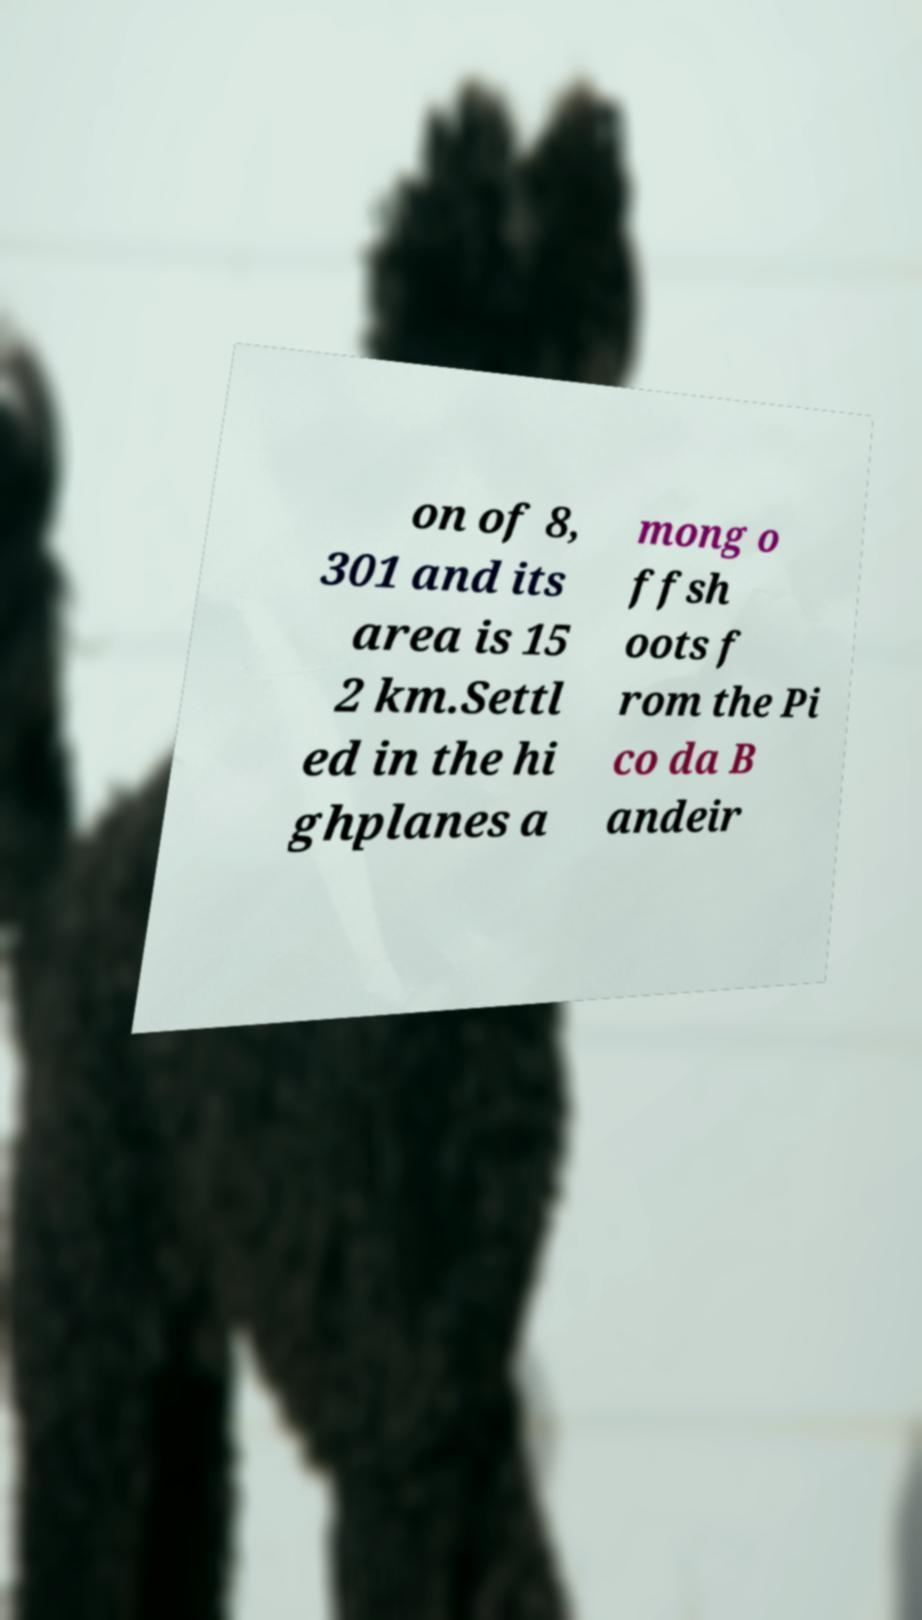Can you read and provide the text displayed in the image?This photo seems to have some interesting text. Can you extract and type it out for me? on of 8, 301 and its area is 15 2 km.Settl ed in the hi ghplanes a mong o ffsh oots f rom the Pi co da B andeir 